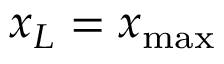Convert formula to latex. <formula><loc_0><loc_0><loc_500><loc_500>x _ { L } = x _ { \max }</formula> 